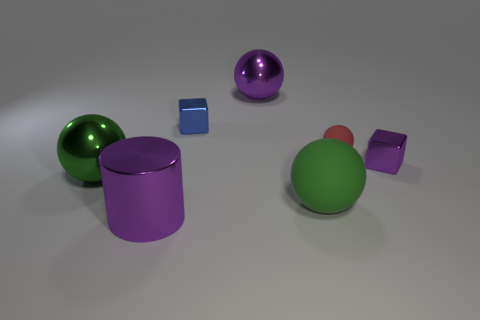Subtract all gray spheres. Subtract all red cubes. How many spheres are left? 4 Add 3 green metallic objects. How many objects exist? 10 Subtract all blocks. How many objects are left? 5 Add 5 small shiny things. How many small shiny things exist? 7 Subtract 1 purple cylinders. How many objects are left? 6 Subtract all big green shiny objects. Subtract all large shiny things. How many objects are left? 3 Add 5 big green shiny things. How many big green shiny things are left? 6 